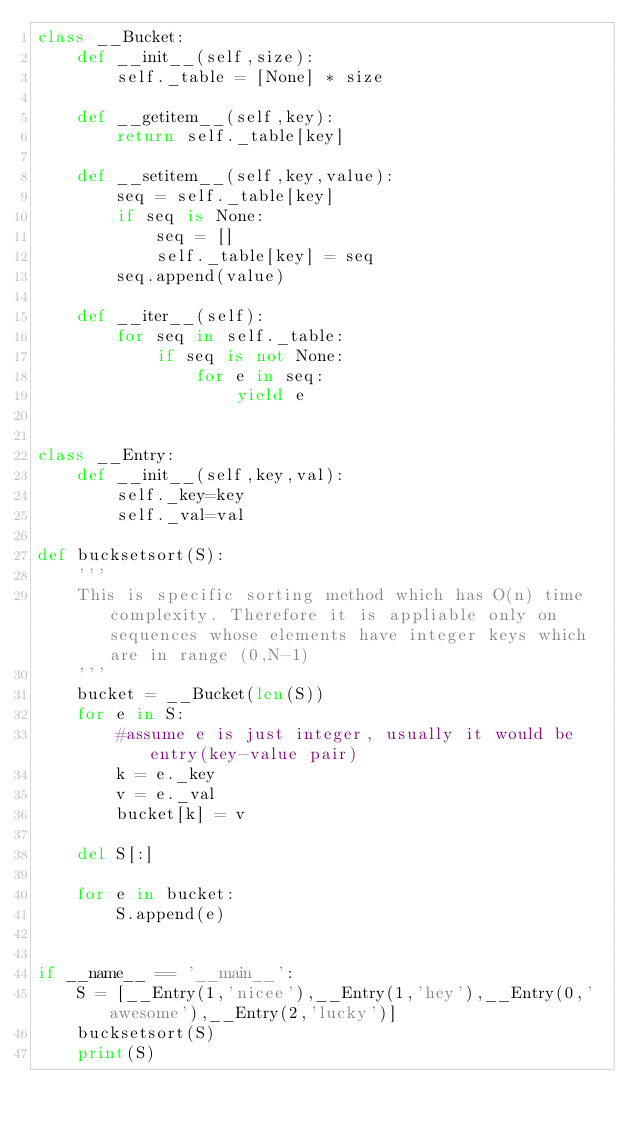<code> <loc_0><loc_0><loc_500><loc_500><_Python_>class __Bucket:
    def __init__(self,size):
        self._table = [None] * size
        
    def __getitem__(self,key):
        return self._table[key]   
    
    def __setitem__(self,key,value):
        seq = self._table[key]
        if seq is None:
            seq = []
            self._table[key] = seq
        seq.append(value)
    
    def __iter__(self):
        for seq in self._table:
            if seq is not None:
                for e in seq:
                    yield e


class __Entry:
    def __init__(self,key,val):
        self._key=key
        self._val=val    

def bucksetsort(S):
    '''
    This is specific sorting method which has O(n) time complexity. Therefore it is appliable only on sequences whose elements have integer keys which are in range (0,N-1)
    '''
    bucket = __Bucket(len(S))
    for e in S:
        #assume e is just integer, usually it would be entry(key-value pair)
        k = e._key
        v = e._val
        bucket[k] = v
    
    del S[:]

    for e in bucket:
        S.append(e)
        

if __name__ == '__main__':
    S = [__Entry(1,'nicee'),__Entry(1,'hey'),__Entry(0,'awesome'),__Entry(2,'lucky')]
    bucksetsort(S)
    print(S)
    
    </code> 